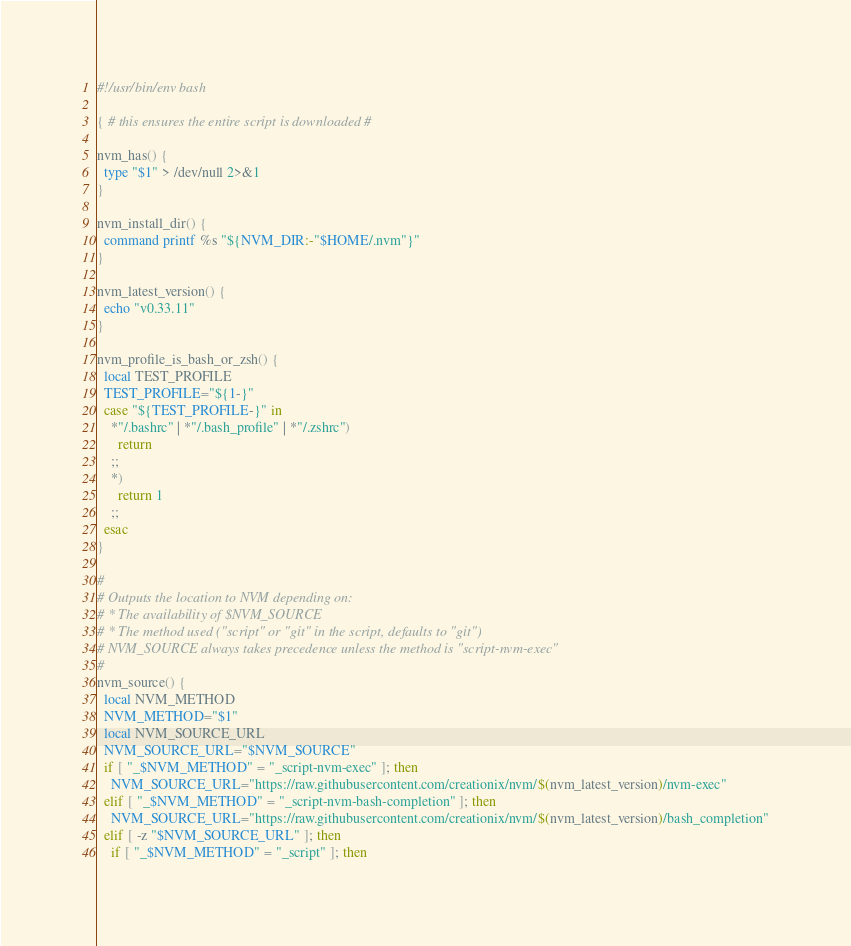<code> <loc_0><loc_0><loc_500><loc_500><_Bash_>#!/usr/bin/env bash

{ # this ensures the entire script is downloaded #

nvm_has() {
  type "$1" > /dev/null 2>&1
}

nvm_install_dir() {
  command printf %s "${NVM_DIR:-"$HOME/.nvm"}"
}

nvm_latest_version() {
  echo "v0.33.11"
}

nvm_profile_is_bash_or_zsh() {
  local TEST_PROFILE
  TEST_PROFILE="${1-}"
  case "${TEST_PROFILE-}" in
    *"/.bashrc" | *"/.bash_profile" | *"/.zshrc")
      return
    ;;
    *)
      return 1
    ;;
  esac
}

#
# Outputs the location to NVM depending on:
# * The availability of $NVM_SOURCE
# * The method used ("script" or "git" in the script, defaults to "git")
# NVM_SOURCE always takes precedence unless the method is "script-nvm-exec"
#
nvm_source() {
  local NVM_METHOD
  NVM_METHOD="$1"
  local NVM_SOURCE_URL
  NVM_SOURCE_URL="$NVM_SOURCE"
  if [ "_$NVM_METHOD" = "_script-nvm-exec" ]; then
    NVM_SOURCE_URL="https://raw.githubusercontent.com/creationix/nvm/$(nvm_latest_version)/nvm-exec"
  elif [ "_$NVM_METHOD" = "_script-nvm-bash-completion" ]; then
    NVM_SOURCE_URL="https://raw.githubusercontent.com/creationix/nvm/$(nvm_latest_version)/bash_completion"
  elif [ -z "$NVM_SOURCE_URL" ]; then
    if [ "_$NVM_METHOD" = "_script" ]; then</code> 